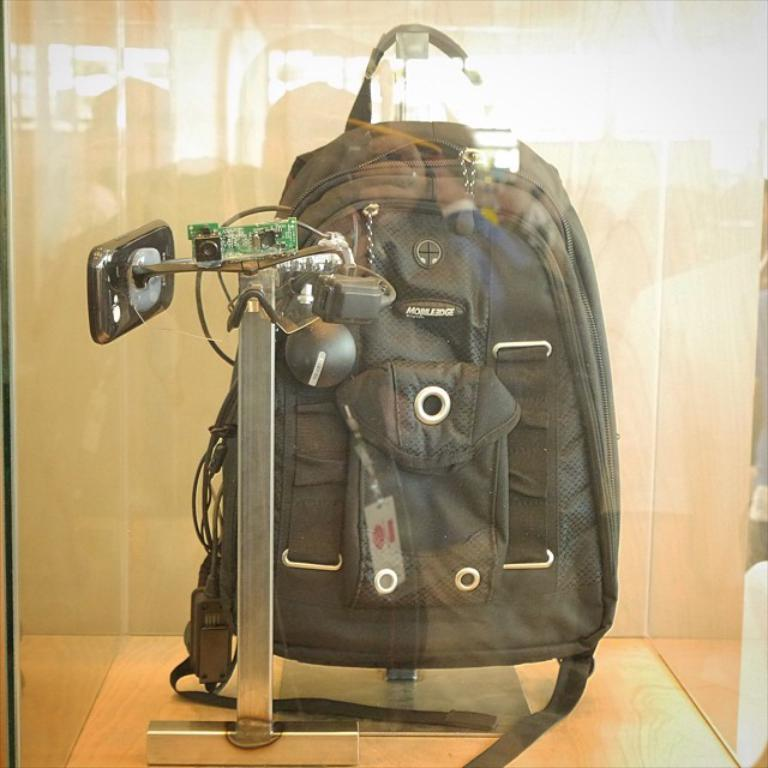What object is visible in the image? There is a bag in the image. How is the bag suspended in the image? The bag is hanging from a metal rod. What is the metal rod placed in? The metal rod is placed in a glass box. What type of poison is stored in the quill inside the glass box? There is no poison or quill present in the image; it features a bag hanging from a metal rod in a glass box. 